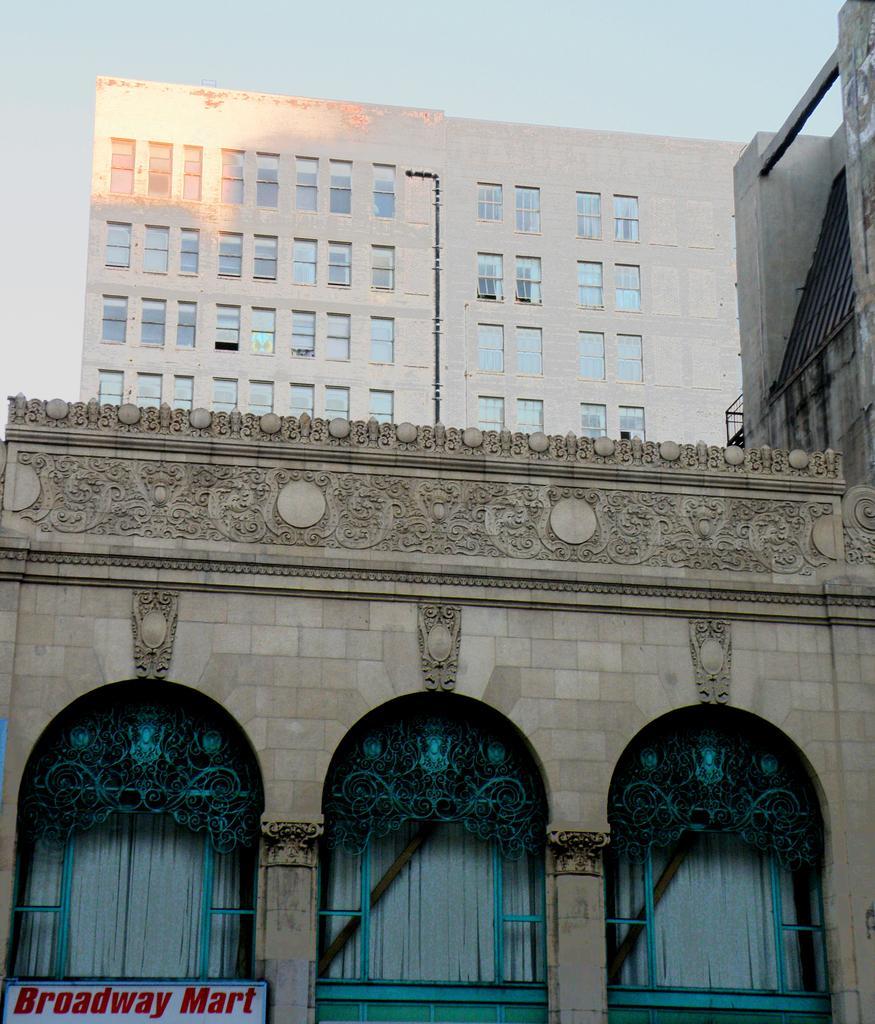Can you describe this image briefly? In this image we can see buildings, there is a building with pipe and windows and a building with windows and curtains and a board with text and sky in the background. 